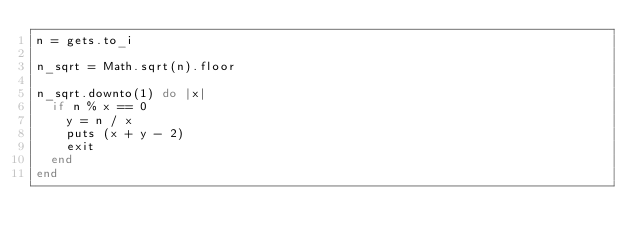<code> <loc_0><loc_0><loc_500><loc_500><_Ruby_>n = gets.to_i

n_sqrt = Math.sqrt(n).floor

n_sqrt.downto(1) do |x|
  if n % x == 0
    y = n / x
    puts (x + y - 2)
    exit
  end
end</code> 